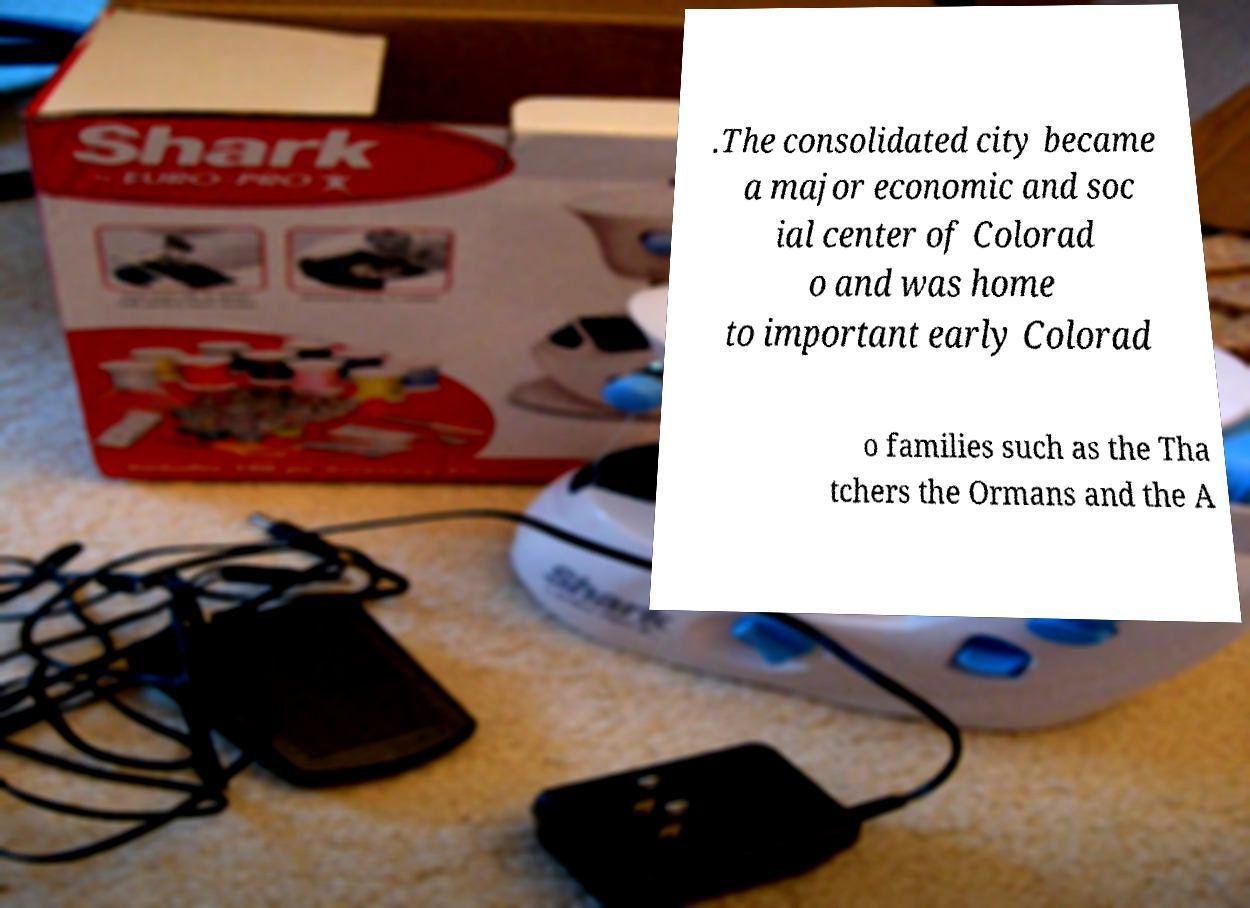I need the written content from this picture converted into text. Can you do that? .The consolidated city became a major economic and soc ial center of Colorad o and was home to important early Colorad o families such as the Tha tchers the Ormans and the A 